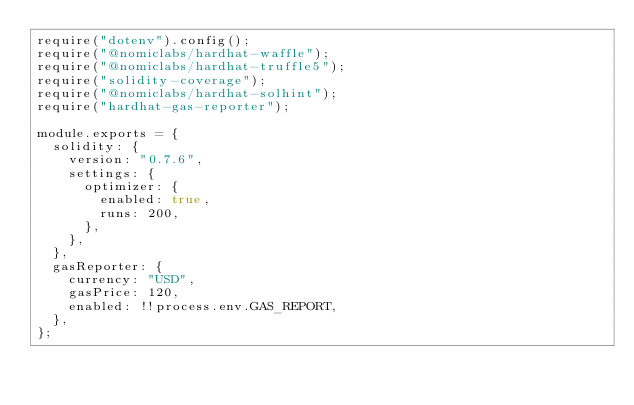<code> <loc_0><loc_0><loc_500><loc_500><_JavaScript_>require("dotenv").config();
require("@nomiclabs/hardhat-waffle");
require("@nomiclabs/hardhat-truffle5");
require("solidity-coverage");
require("@nomiclabs/hardhat-solhint");
require("hardhat-gas-reporter");

module.exports = {
  solidity: {
    version: "0.7.6",
    settings: {
      optimizer: {
        enabled: true,
        runs: 200,
      },
    },
  },
  gasReporter: {
    currency: "USD",
    gasPrice: 120,
    enabled: !!process.env.GAS_REPORT,
  },
};
</code> 